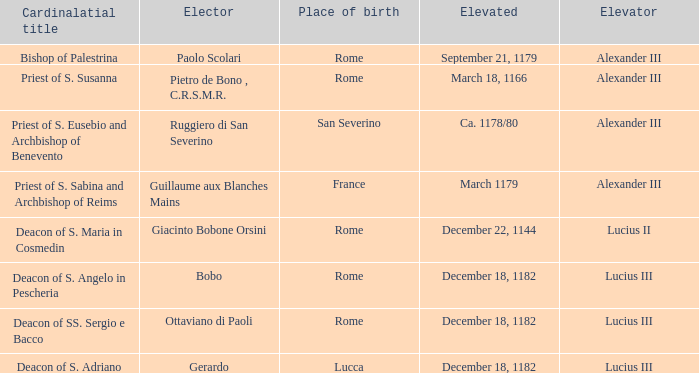What Elector has an Elevator of Alexander III and a Cardinalatial title of Bishop of Palestrina? Paolo Scolari. 